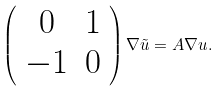<formula> <loc_0><loc_0><loc_500><loc_500>\left ( \begin{array} { c c } 0 & 1 \\ - 1 & 0 \end{array} \right ) \nabla \tilde { u } = A \nabla u .</formula> 